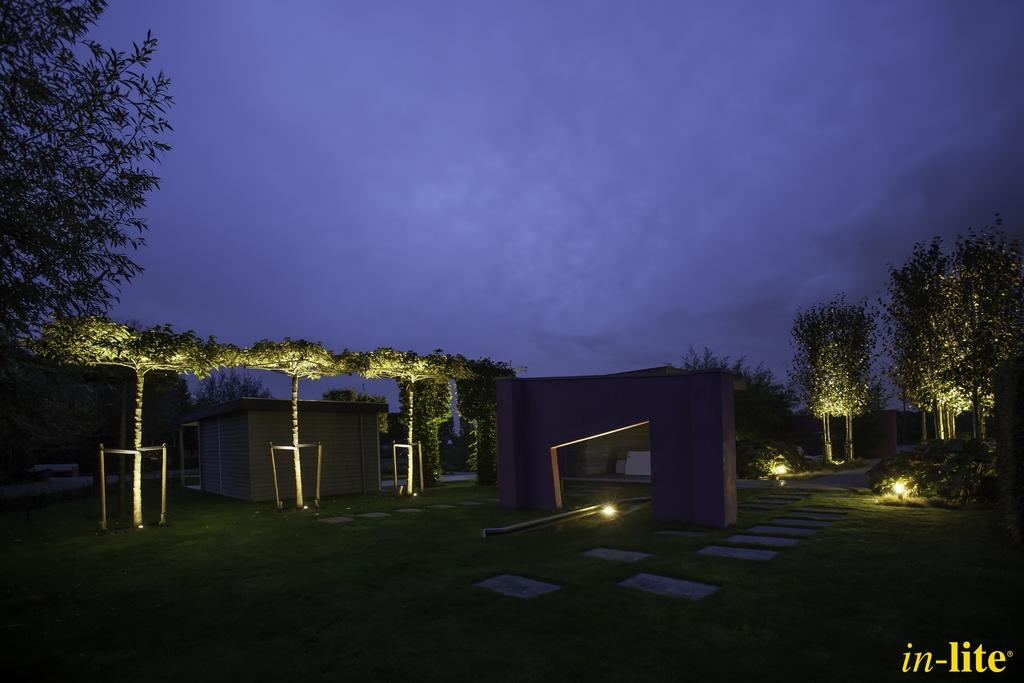What can be found in the bottom right corner of the image? There is a watermark in the bottom right of the image. What is located in the background of the image? There is a shelter, trees, lights, and grass on the ground in the background of the image. What can be seen in the sky in the image? Clouds are visible in the sky. What color is the answer to the question in the image? There is no question or answer present in the image, so it is not possible to determine the color of an answer. 